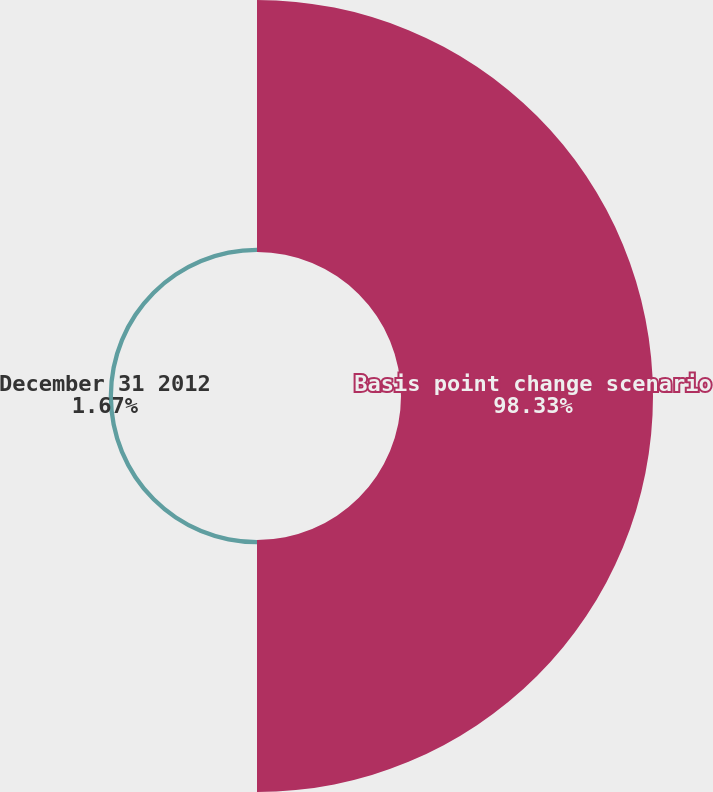Convert chart. <chart><loc_0><loc_0><loc_500><loc_500><pie_chart><fcel>Basis point change scenario<fcel>December 31 2012<nl><fcel>98.33%<fcel>1.67%<nl></chart> 